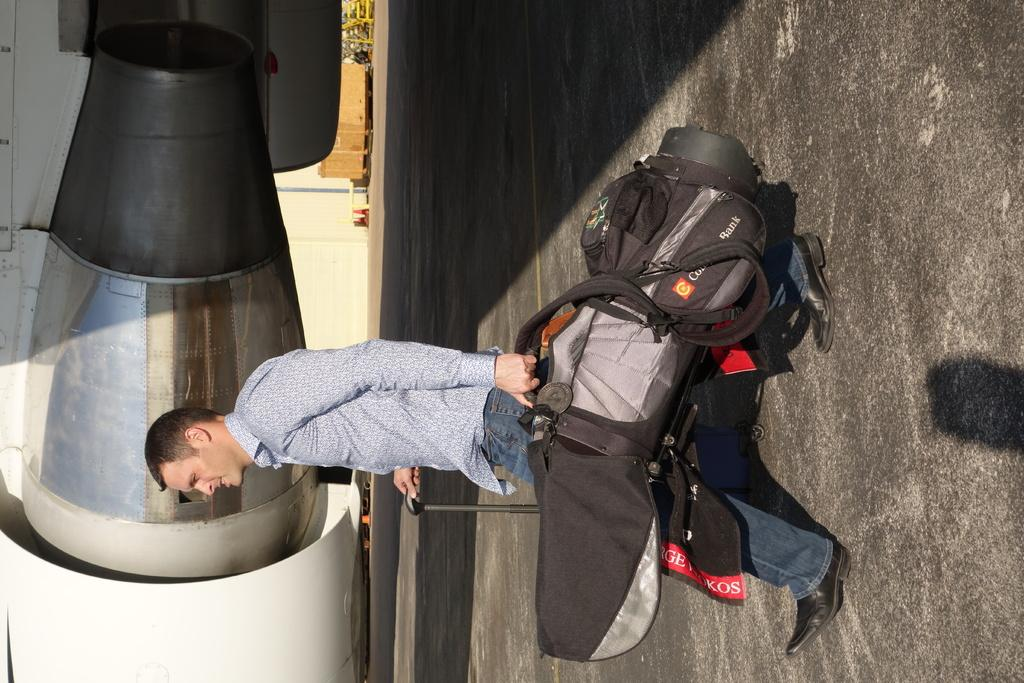What is the main subject of the image? There is a person in the image. Can you describe the person's attire? The person is wearing a shirt and pants. What is the person doing in the image? The person is standing. What is the person holding in the image? The person is holding a bag and a stick in his hand. What can be seen in the background of the image? There is a flag, an aircraft, and other objects in the background of the image. Where is the throne located in the image? There is no throne present in the image. What type of cap is the person wearing in the image? The person is not wearing a cap in the image. What kind of pets can be seen in the image? There are no pets visible in the image. 